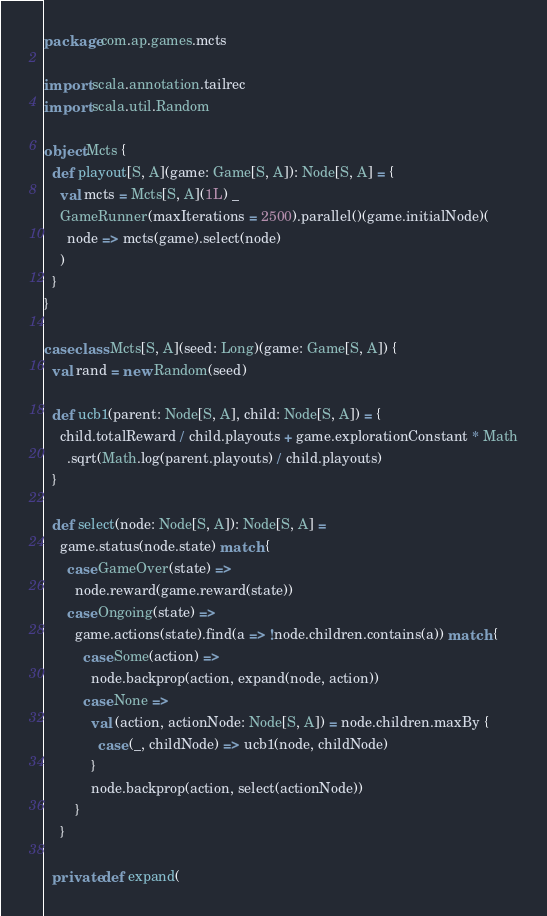<code> <loc_0><loc_0><loc_500><loc_500><_Scala_>package com.ap.games.mcts

import scala.annotation.tailrec
import scala.util.Random

object Mcts {
  def playout[S, A](game: Game[S, A]): Node[S, A] = {
    val mcts = Mcts[S, A](1L) _
    GameRunner(maxIterations = 2500).parallel()(game.initialNode)(
      node => mcts(game).select(node)
    )
  }
}

case class Mcts[S, A](seed: Long)(game: Game[S, A]) {
  val rand = new Random(seed)

  def ucb1(parent: Node[S, A], child: Node[S, A]) = {
    child.totalReward / child.playouts + game.explorationConstant * Math
      .sqrt(Math.log(parent.playouts) / child.playouts)
  }

  def select(node: Node[S, A]): Node[S, A] =
    game.status(node.state) match {
      case GameOver(state) =>
        node.reward(game.reward(state))
      case Ongoing(state) =>
        game.actions(state).find(a => !node.children.contains(a)) match {
          case Some(action) =>
            node.backprop(action, expand(node, action))
          case None =>
            val (action, actionNode: Node[S, A]) = node.children.maxBy {
              case (_, childNode) => ucb1(node, childNode)
            }
            node.backprop(action, select(actionNode))
        }
    }

  private def expand(</code> 